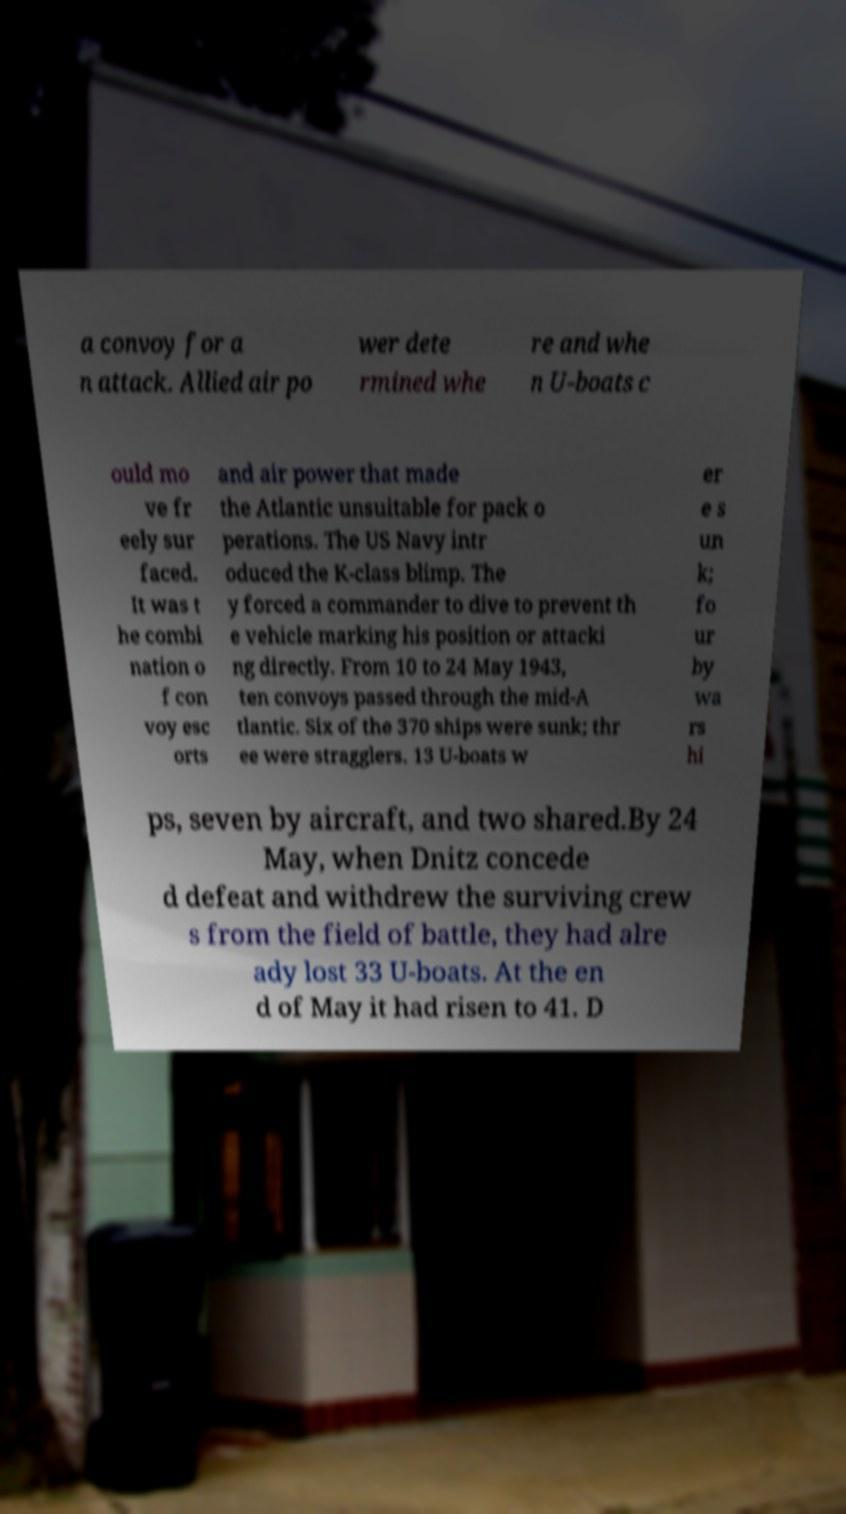There's text embedded in this image that I need extracted. Can you transcribe it verbatim? a convoy for a n attack. Allied air po wer dete rmined whe re and whe n U-boats c ould mo ve fr eely sur faced. It was t he combi nation o f con voy esc orts and air power that made the Atlantic unsuitable for pack o perations. The US Navy intr oduced the K-class blimp. The y forced a commander to dive to prevent th e vehicle marking his position or attacki ng directly. From 10 to 24 May 1943, ten convoys passed through the mid-A tlantic. Six of the 370 ships were sunk; thr ee were stragglers. 13 U-boats w er e s un k; fo ur by wa rs hi ps, seven by aircraft, and two shared.By 24 May, when Dnitz concede d defeat and withdrew the surviving crew s from the field of battle, they had alre ady lost 33 U-boats. At the en d of May it had risen to 41. D 